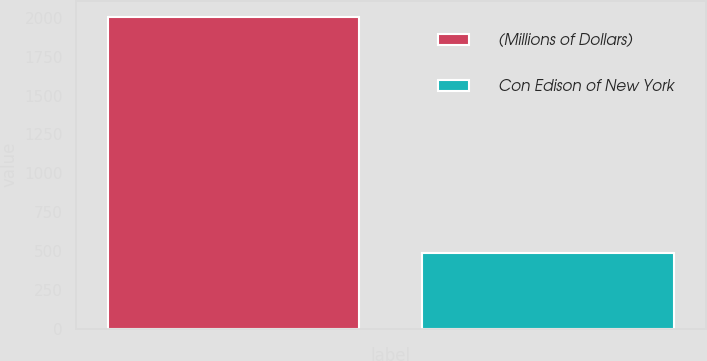<chart> <loc_0><loc_0><loc_500><loc_500><bar_chart><fcel>(Millions of Dollars)<fcel>Con Edison of New York<nl><fcel>2010<fcel>485<nl></chart> 